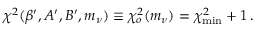<formula> <loc_0><loc_0><loc_500><loc_500>\chi ^ { 2 } ( \beta ^ { \prime } , A ^ { \prime } , B ^ { \prime } , m _ { \nu } ) \equiv \chi _ { o } ^ { 2 } ( m _ { \nu } ) = \chi _ { \min } ^ { 2 } + 1 \, .</formula> 